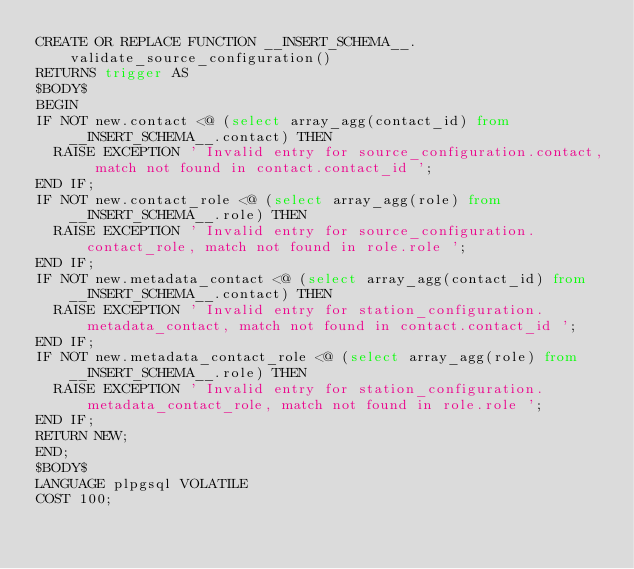Convert code to text. <code><loc_0><loc_0><loc_500><loc_500><_SQL_>CREATE OR REPLACE FUNCTION __INSERT_SCHEMA__.validate_source_configuration()
RETURNS trigger AS 
$BODY$
BEGIN
IF NOT new.contact <@ (select array_agg(contact_id) from __INSERT_SCHEMA__.contact) THEN
  RAISE EXCEPTION ' Invalid entry for source_configuration.contact, match not found in contact.contact_id ';
END IF;
IF NOT new.contact_role <@ (select array_agg(role) from __INSERT_SCHEMA__.role) THEN
  RAISE EXCEPTION ' Invalid entry for source_configuration.contact_role, match not found in role.role ';
END IF;
IF NOT new.metadata_contact <@ (select array_agg(contact_id) from __INSERT_SCHEMA__.contact) THEN
  RAISE EXCEPTION ' Invalid entry for station_configuration.metadata_contact, match not found in contact.contact_id ';
END IF;
IF NOT new.metadata_contact_role <@ (select array_agg(role) from __INSERT_SCHEMA__.role) THEN
  RAISE EXCEPTION ' Invalid entry for station_configuration.metadata_contact_role, match not found in role.role ';
END IF;
RETURN NEW;
END;
$BODY$
LANGUAGE plpgsql VOLATILE
COST 100;


</code> 